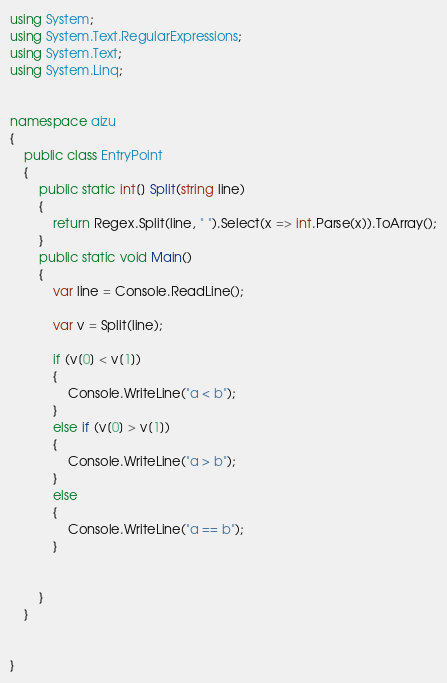<code> <loc_0><loc_0><loc_500><loc_500><_C#_>using System;
using System.Text.RegularExpressions;
using System.Text;
using System.Linq;


namespace aizu
{
	public class EntryPoint
	{
		public static int[] Split(string line)
		{
			return Regex.Split(line, " ").Select(x => int.Parse(x)).ToArray();
		}
		public static void Main()
		{
			var line = Console.ReadLine();
			
			var v = Split(line);
			
			if (v[0] < v[1])
			{
				Console.WriteLine("a < b");
			}
			else if (v[0] > v[1])
			{
				Console.WriteLine("a > b");
			}
			else
			{
				Console.WriteLine("a == b");
			}
			
			
		}
	}


}</code> 